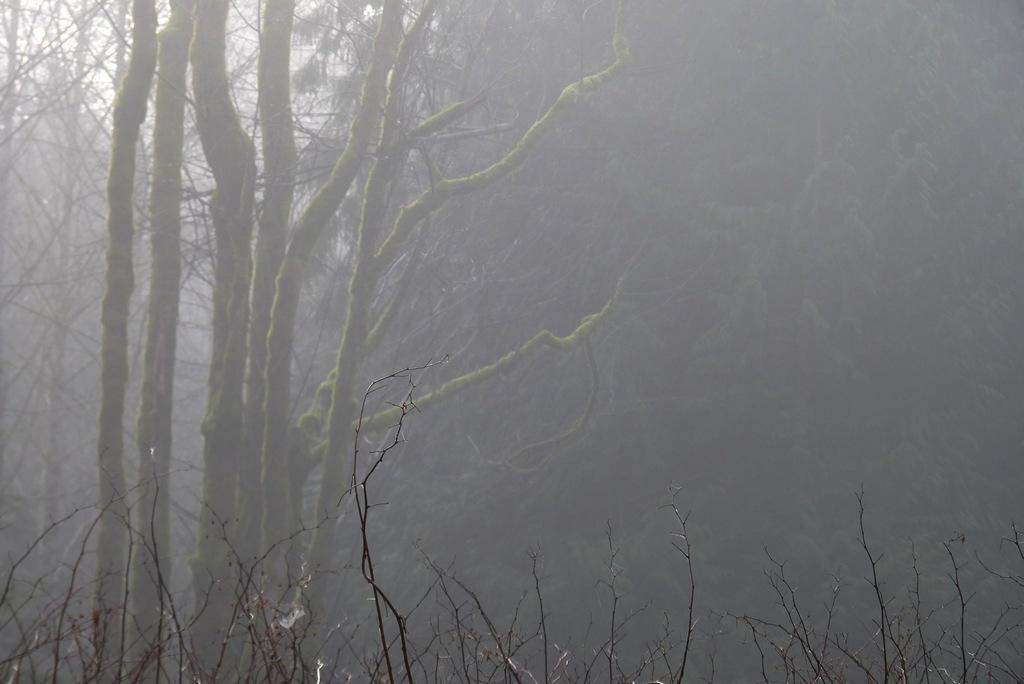Can you describe this image briefly? In this picture we can see fig, trees and plants. 